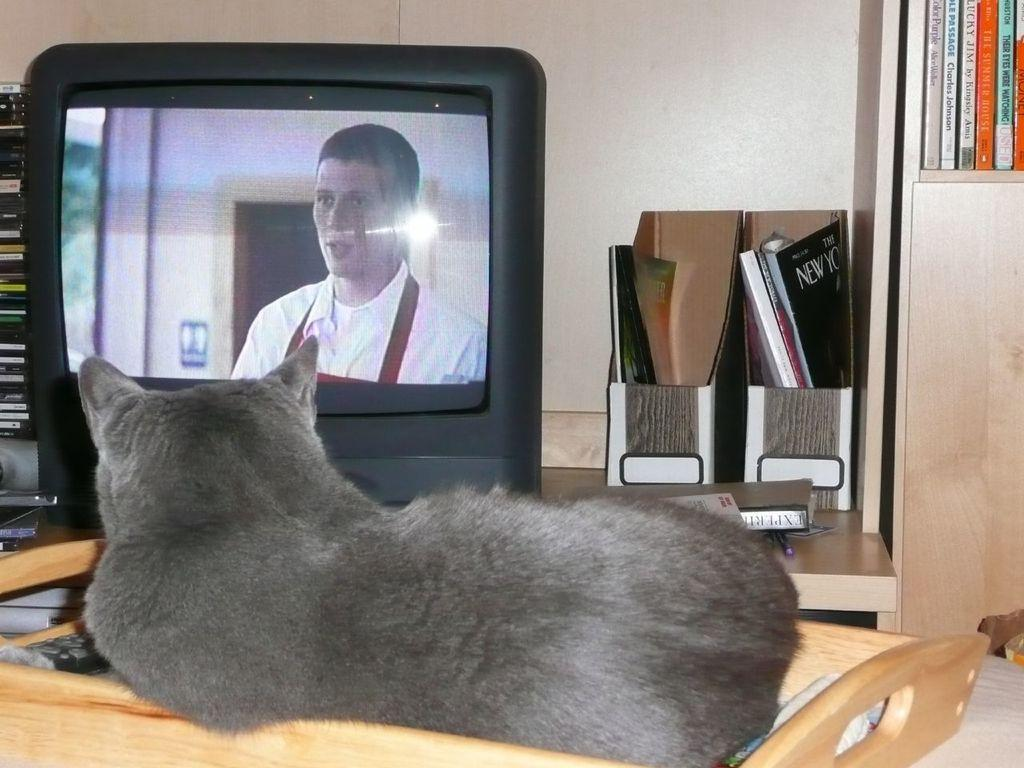What electronic device is present in the image? There is a television in the image. What type of animal can be seen in the image? There is a cat in the image. What reading materials are present in the image? There are magazines on a board and books arranged in a rack in the image. What writing instrument is visible in the image? There is a pen on the table in the image. What type of border is visible around the cat in the image? There is no border visible around the cat in the image; it is a real cat and not a drawing or photograph with a border. Is there any milk present in the image? There is no milk visible in the image. Can you see a glove in the image? There is no glove present in the image. 